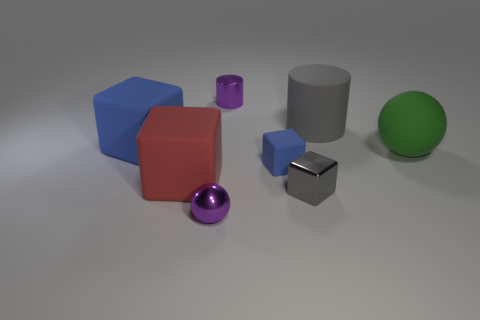What shape is the gray matte thing?
Keep it short and to the point. Cylinder. How many purple objects are either large shiny cylinders or shiny objects?
Provide a short and direct response. 2. How many other things are there of the same material as the green object?
Provide a succinct answer. 4. Do the big matte thing that is in front of the small blue rubber block and the gray rubber object have the same shape?
Provide a short and direct response. No. Is there a big gray matte cylinder?
Your answer should be compact. Yes. Are there any other things that are the same shape as the green thing?
Your response must be concise. Yes. Is the number of tiny gray metal cubes behind the tiny cylinder greater than the number of large cylinders?
Offer a very short reply. No. There is a tiny purple metallic ball; are there any blue matte objects left of it?
Ensure brevity in your answer.  Yes. Do the red thing and the matte sphere have the same size?
Your response must be concise. Yes. The gray object that is the same shape as the tiny blue object is what size?
Offer a terse response. Small. 